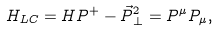<formula> <loc_0><loc_0><loc_500><loc_500>H _ { L C } = H P ^ { + } - \vec { P } ^ { 2 } _ { \, \perp } = P ^ { \mu } P _ { \mu } ,</formula> 